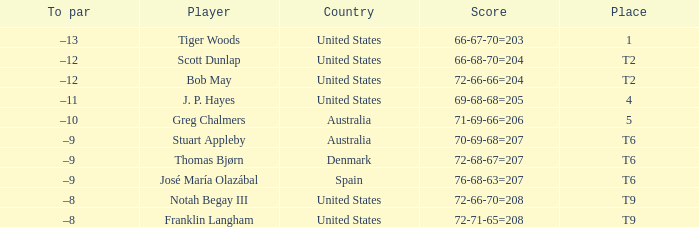What is the country of the player with a t6 place? Australia, Denmark, Spain. 